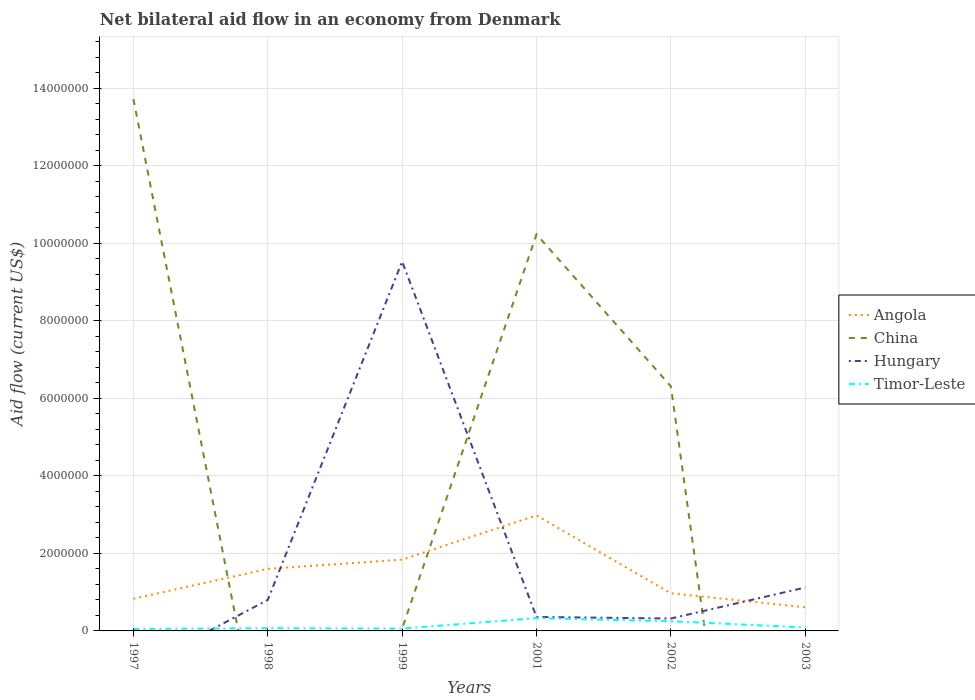Does the line corresponding to China intersect with the line corresponding to Angola?
Offer a very short reply. Yes. Across all years, what is the maximum net bilateral aid flow in Hungary?
Offer a very short reply. 0. What is the total net bilateral aid flow in China in the graph?
Ensure brevity in your answer.  3.49e+06. What is the difference between the highest and the second highest net bilateral aid flow in Hungary?
Your answer should be compact. 9.53e+06. Is the net bilateral aid flow in Timor-Leste strictly greater than the net bilateral aid flow in China over the years?
Your answer should be compact. No. How many years are there in the graph?
Offer a terse response. 6. Are the values on the major ticks of Y-axis written in scientific E-notation?
Provide a short and direct response. No. Does the graph contain grids?
Keep it short and to the point. Yes. How many legend labels are there?
Make the answer very short. 4. What is the title of the graph?
Make the answer very short. Net bilateral aid flow in an economy from Denmark. Does "Other small states" appear as one of the legend labels in the graph?
Ensure brevity in your answer.  No. What is the label or title of the X-axis?
Offer a terse response. Years. What is the Aid flow (current US$) of Angola in 1997?
Make the answer very short. 8.30e+05. What is the Aid flow (current US$) of China in 1997?
Keep it short and to the point. 1.37e+07. What is the Aid flow (current US$) of Angola in 1998?
Give a very brief answer. 1.60e+06. What is the Aid flow (current US$) of Angola in 1999?
Keep it short and to the point. 1.84e+06. What is the Aid flow (current US$) of Hungary in 1999?
Give a very brief answer. 9.53e+06. What is the Aid flow (current US$) of Angola in 2001?
Offer a terse response. 2.98e+06. What is the Aid flow (current US$) in China in 2001?
Give a very brief answer. 1.02e+07. What is the Aid flow (current US$) of Timor-Leste in 2001?
Offer a terse response. 3.30e+05. What is the Aid flow (current US$) in Angola in 2002?
Offer a very short reply. 9.70e+05. What is the Aid flow (current US$) of China in 2002?
Ensure brevity in your answer.  6.31e+06. What is the Aid flow (current US$) in Hungary in 2003?
Give a very brief answer. 1.12e+06. What is the Aid flow (current US$) of Timor-Leste in 2003?
Provide a succinct answer. 9.00e+04. Across all years, what is the maximum Aid flow (current US$) of Angola?
Your answer should be very brief. 2.98e+06. Across all years, what is the maximum Aid flow (current US$) in China?
Keep it short and to the point. 1.37e+07. Across all years, what is the maximum Aid flow (current US$) of Hungary?
Make the answer very short. 9.53e+06. Across all years, what is the minimum Aid flow (current US$) of Angola?
Make the answer very short. 6.10e+05. Across all years, what is the minimum Aid flow (current US$) of Timor-Leste?
Your response must be concise. 5.00e+04. What is the total Aid flow (current US$) in Angola in the graph?
Your answer should be very brief. 8.83e+06. What is the total Aid flow (current US$) of China in the graph?
Your response must be concise. 3.03e+07. What is the total Aid flow (current US$) in Hungary in the graph?
Your answer should be compact. 1.21e+07. What is the total Aid flow (current US$) of Timor-Leste in the graph?
Keep it short and to the point. 8.50e+05. What is the difference between the Aid flow (current US$) of Angola in 1997 and that in 1998?
Your answer should be very brief. -7.70e+05. What is the difference between the Aid flow (current US$) in Timor-Leste in 1997 and that in 1998?
Make the answer very short. -2.00e+04. What is the difference between the Aid flow (current US$) of Angola in 1997 and that in 1999?
Offer a terse response. -1.01e+06. What is the difference between the Aid flow (current US$) in China in 1997 and that in 1999?
Offer a terse response. 1.37e+07. What is the difference between the Aid flow (current US$) of Timor-Leste in 1997 and that in 1999?
Give a very brief answer. -10000. What is the difference between the Aid flow (current US$) in Angola in 1997 and that in 2001?
Make the answer very short. -2.15e+06. What is the difference between the Aid flow (current US$) in China in 1997 and that in 2001?
Offer a terse response. 3.49e+06. What is the difference between the Aid flow (current US$) of Timor-Leste in 1997 and that in 2001?
Offer a very short reply. -2.80e+05. What is the difference between the Aid flow (current US$) of China in 1997 and that in 2002?
Your answer should be compact. 7.41e+06. What is the difference between the Aid flow (current US$) in Timor-Leste in 1997 and that in 2003?
Keep it short and to the point. -4.00e+04. What is the difference between the Aid flow (current US$) of Hungary in 1998 and that in 1999?
Ensure brevity in your answer.  -8.73e+06. What is the difference between the Aid flow (current US$) in Angola in 1998 and that in 2001?
Keep it short and to the point. -1.38e+06. What is the difference between the Aid flow (current US$) in Hungary in 1998 and that in 2001?
Provide a short and direct response. 4.40e+05. What is the difference between the Aid flow (current US$) in Timor-Leste in 1998 and that in 2001?
Make the answer very short. -2.60e+05. What is the difference between the Aid flow (current US$) in Angola in 1998 and that in 2002?
Offer a terse response. 6.30e+05. What is the difference between the Aid flow (current US$) of Hungary in 1998 and that in 2002?
Provide a succinct answer. 4.80e+05. What is the difference between the Aid flow (current US$) in Timor-Leste in 1998 and that in 2002?
Your response must be concise. -1.80e+05. What is the difference between the Aid flow (current US$) of Angola in 1998 and that in 2003?
Provide a short and direct response. 9.90e+05. What is the difference between the Aid flow (current US$) in Hungary in 1998 and that in 2003?
Provide a short and direct response. -3.20e+05. What is the difference between the Aid flow (current US$) of Angola in 1999 and that in 2001?
Your answer should be compact. -1.14e+06. What is the difference between the Aid flow (current US$) of China in 1999 and that in 2001?
Your answer should be very brief. -1.02e+07. What is the difference between the Aid flow (current US$) in Hungary in 1999 and that in 2001?
Your answer should be very brief. 9.17e+06. What is the difference between the Aid flow (current US$) in Timor-Leste in 1999 and that in 2001?
Your answer should be compact. -2.70e+05. What is the difference between the Aid flow (current US$) of Angola in 1999 and that in 2002?
Offer a terse response. 8.70e+05. What is the difference between the Aid flow (current US$) of China in 1999 and that in 2002?
Offer a very short reply. -6.25e+06. What is the difference between the Aid flow (current US$) of Hungary in 1999 and that in 2002?
Your response must be concise. 9.21e+06. What is the difference between the Aid flow (current US$) in Timor-Leste in 1999 and that in 2002?
Your answer should be very brief. -1.90e+05. What is the difference between the Aid flow (current US$) of Angola in 1999 and that in 2003?
Keep it short and to the point. 1.23e+06. What is the difference between the Aid flow (current US$) of Hungary in 1999 and that in 2003?
Give a very brief answer. 8.41e+06. What is the difference between the Aid flow (current US$) of Angola in 2001 and that in 2002?
Your response must be concise. 2.01e+06. What is the difference between the Aid flow (current US$) in China in 2001 and that in 2002?
Make the answer very short. 3.92e+06. What is the difference between the Aid flow (current US$) of Hungary in 2001 and that in 2002?
Ensure brevity in your answer.  4.00e+04. What is the difference between the Aid flow (current US$) of Angola in 2001 and that in 2003?
Give a very brief answer. 2.37e+06. What is the difference between the Aid flow (current US$) of Hungary in 2001 and that in 2003?
Provide a short and direct response. -7.60e+05. What is the difference between the Aid flow (current US$) of Timor-Leste in 2001 and that in 2003?
Provide a short and direct response. 2.40e+05. What is the difference between the Aid flow (current US$) of Angola in 2002 and that in 2003?
Offer a very short reply. 3.60e+05. What is the difference between the Aid flow (current US$) in Hungary in 2002 and that in 2003?
Make the answer very short. -8.00e+05. What is the difference between the Aid flow (current US$) of Angola in 1997 and the Aid flow (current US$) of Hungary in 1998?
Make the answer very short. 3.00e+04. What is the difference between the Aid flow (current US$) of Angola in 1997 and the Aid flow (current US$) of Timor-Leste in 1998?
Your answer should be very brief. 7.60e+05. What is the difference between the Aid flow (current US$) in China in 1997 and the Aid flow (current US$) in Hungary in 1998?
Make the answer very short. 1.29e+07. What is the difference between the Aid flow (current US$) in China in 1997 and the Aid flow (current US$) in Timor-Leste in 1998?
Ensure brevity in your answer.  1.36e+07. What is the difference between the Aid flow (current US$) of Angola in 1997 and the Aid flow (current US$) of China in 1999?
Provide a short and direct response. 7.70e+05. What is the difference between the Aid flow (current US$) of Angola in 1997 and the Aid flow (current US$) of Hungary in 1999?
Your answer should be compact. -8.70e+06. What is the difference between the Aid flow (current US$) of Angola in 1997 and the Aid flow (current US$) of Timor-Leste in 1999?
Keep it short and to the point. 7.70e+05. What is the difference between the Aid flow (current US$) in China in 1997 and the Aid flow (current US$) in Hungary in 1999?
Ensure brevity in your answer.  4.19e+06. What is the difference between the Aid flow (current US$) in China in 1997 and the Aid flow (current US$) in Timor-Leste in 1999?
Your answer should be very brief. 1.37e+07. What is the difference between the Aid flow (current US$) in Angola in 1997 and the Aid flow (current US$) in China in 2001?
Provide a short and direct response. -9.40e+06. What is the difference between the Aid flow (current US$) of Angola in 1997 and the Aid flow (current US$) of Hungary in 2001?
Your response must be concise. 4.70e+05. What is the difference between the Aid flow (current US$) in Angola in 1997 and the Aid flow (current US$) in Timor-Leste in 2001?
Your answer should be very brief. 5.00e+05. What is the difference between the Aid flow (current US$) in China in 1997 and the Aid flow (current US$) in Hungary in 2001?
Provide a short and direct response. 1.34e+07. What is the difference between the Aid flow (current US$) in China in 1997 and the Aid flow (current US$) in Timor-Leste in 2001?
Make the answer very short. 1.34e+07. What is the difference between the Aid flow (current US$) in Angola in 1997 and the Aid flow (current US$) in China in 2002?
Provide a short and direct response. -5.48e+06. What is the difference between the Aid flow (current US$) in Angola in 1997 and the Aid flow (current US$) in Hungary in 2002?
Provide a succinct answer. 5.10e+05. What is the difference between the Aid flow (current US$) in Angola in 1997 and the Aid flow (current US$) in Timor-Leste in 2002?
Offer a very short reply. 5.80e+05. What is the difference between the Aid flow (current US$) of China in 1997 and the Aid flow (current US$) of Hungary in 2002?
Keep it short and to the point. 1.34e+07. What is the difference between the Aid flow (current US$) of China in 1997 and the Aid flow (current US$) of Timor-Leste in 2002?
Offer a very short reply. 1.35e+07. What is the difference between the Aid flow (current US$) of Angola in 1997 and the Aid flow (current US$) of Timor-Leste in 2003?
Provide a succinct answer. 7.40e+05. What is the difference between the Aid flow (current US$) of China in 1997 and the Aid flow (current US$) of Hungary in 2003?
Offer a terse response. 1.26e+07. What is the difference between the Aid flow (current US$) in China in 1997 and the Aid flow (current US$) in Timor-Leste in 2003?
Your answer should be very brief. 1.36e+07. What is the difference between the Aid flow (current US$) of Angola in 1998 and the Aid flow (current US$) of China in 1999?
Make the answer very short. 1.54e+06. What is the difference between the Aid flow (current US$) in Angola in 1998 and the Aid flow (current US$) in Hungary in 1999?
Your response must be concise. -7.93e+06. What is the difference between the Aid flow (current US$) in Angola in 1998 and the Aid flow (current US$) in Timor-Leste in 1999?
Make the answer very short. 1.54e+06. What is the difference between the Aid flow (current US$) in Hungary in 1998 and the Aid flow (current US$) in Timor-Leste in 1999?
Your response must be concise. 7.40e+05. What is the difference between the Aid flow (current US$) of Angola in 1998 and the Aid flow (current US$) of China in 2001?
Your response must be concise. -8.63e+06. What is the difference between the Aid flow (current US$) of Angola in 1998 and the Aid flow (current US$) of Hungary in 2001?
Offer a very short reply. 1.24e+06. What is the difference between the Aid flow (current US$) in Angola in 1998 and the Aid flow (current US$) in Timor-Leste in 2001?
Give a very brief answer. 1.27e+06. What is the difference between the Aid flow (current US$) in Hungary in 1998 and the Aid flow (current US$) in Timor-Leste in 2001?
Offer a very short reply. 4.70e+05. What is the difference between the Aid flow (current US$) in Angola in 1998 and the Aid flow (current US$) in China in 2002?
Provide a short and direct response. -4.71e+06. What is the difference between the Aid flow (current US$) in Angola in 1998 and the Aid flow (current US$) in Hungary in 2002?
Offer a very short reply. 1.28e+06. What is the difference between the Aid flow (current US$) of Angola in 1998 and the Aid flow (current US$) of Timor-Leste in 2002?
Keep it short and to the point. 1.35e+06. What is the difference between the Aid flow (current US$) in Angola in 1998 and the Aid flow (current US$) in Timor-Leste in 2003?
Provide a succinct answer. 1.51e+06. What is the difference between the Aid flow (current US$) of Hungary in 1998 and the Aid flow (current US$) of Timor-Leste in 2003?
Your answer should be compact. 7.10e+05. What is the difference between the Aid flow (current US$) in Angola in 1999 and the Aid flow (current US$) in China in 2001?
Provide a short and direct response. -8.39e+06. What is the difference between the Aid flow (current US$) of Angola in 1999 and the Aid flow (current US$) of Hungary in 2001?
Make the answer very short. 1.48e+06. What is the difference between the Aid flow (current US$) in Angola in 1999 and the Aid flow (current US$) in Timor-Leste in 2001?
Offer a very short reply. 1.51e+06. What is the difference between the Aid flow (current US$) in China in 1999 and the Aid flow (current US$) in Timor-Leste in 2001?
Your answer should be very brief. -2.70e+05. What is the difference between the Aid flow (current US$) of Hungary in 1999 and the Aid flow (current US$) of Timor-Leste in 2001?
Offer a terse response. 9.20e+06. What is the difference between the Aid flow (current US$) of Angola in 1999 and the Aid flow (current US$) of China in 2002?
Your answer should be compact. -4.47e+06. What is the difference between the Aid flow (current US$) of Angola in 1999 and the Aid flow (current US$) of Hungary in 2002?
Your answer should be very brief. 1.52e+06. What is the difference between the Aid flow (current US$) in Angola in 1999 and the Aid flow (current US$) in Timor-Leste in 2002?
Make the answer very short. 1.59e+06. What is the difference between the Aid flow (current US$) of China in 1999 and the Aid flow (current US$) of Timor-Leste in 2002?
Offer a terse response. -1.90e+05. What is the difference between the Aid flow (current US$) of Hungary in 1999 and the Aid flow (current US$) of Timor-Leste in 2002?
Offer a terse response. 9.28e+06. What is the difference between the Aid flow (current US$) in Angola in 1999 and the Aid flow (current US$) in Hungary in 2003?
Provide a short and direct response. 7.20e+05. What is the difference between the Aid flow (current US$) of Angola in 1999 and the Aid flow (current US$) of Timor-Leste in 2003?
Offer a very short reply. 1.75e+06. What is the difference between the Aid flow (current US$) in China in 1999 and the Aid flow (current US$) in Hungary in 2003?
Offer a very short reply. -1.06e+06. What is the difference between the Aid flow (current US$) of Hungary in 1999 and the Aid flow (current US$) of Timor-Leste in 2003?
Offer a terse response. 9.44e+06. What is the difference between the Aid flow (current US$) of Angola in 2001 and the Aid flow (current US$) of China in 2002?
Provide a short and direct response. -3.33e+06. What is the difference between the Aid flow (current US$) of Angola in 2001 and the Aid flow (current US$) of Hungary in 2002?
Ensure brevity in your answer.  2.66e+06. What is the difference between the Aid flow (current US$) of Angola in 2001 and the Aid flow (current US$) of Timor-Leste in 2002?
Ensure brevity in your answer.  2.73e+06. What is the difference between the Aid flow (current US$) in China in 2001 and the Aid flow (current US$) in Hungary in 2002?
Your response must be concise. 9.91e+06. What is the difference between the Aid flow (current US$) of China in 2001 and the Aid flow (current US$) of Timor-Leste in 2002?
Ensure brevity in your answer.  9.98e+06. What is the difference between the Aid flow (current US$) of Angola in 2001 and the Aid flow (current US$) of Hungary in 2003?
Make the answer very short. 1.86e+06. What is the difference between the Aid flow (current US$) in Angola in 2001 and the Aid flow (current US$) in Timor-Leste in 2003?
Give a very brief answer. 2.89e+06. What is the difference between the Aid flow (current US$) in China in 2001 and the Aid flow (current US$) in Hungary in 2003?
Provide a succinct answer. 9.11e+06. What is the difference between the Aid flow (current US$) of China in 2001 and the Aid flow (current US$) of Timor-Leste in 2003?
Your response must be concise. 1.01e+07. What is the difference between the Aid flow (current US$) in Angola in 2002 and the Aid flow (current US$) in Hungary in 2003?
Ensure brevity in your answer.  -1.50e+05. What is the difference between the Aid flow (current US$) in Angola in 2002 and the Aid flow (current US$) in Timor-Leste in 2003?
Your answer should be compact. 8.80e+05. What is the difference between the Aid flow (current US$) of China in 2002 and the Aid flow (current US$) of Hungary in 2003?
Your answer should be compact. 5.19e+06. What is the difference between the Aid flow (current US$) in China in 2002 and the Aid flow (current US$) in Timor-Leste in 2003?
Provide a succinct answer. 6.22e+06. What is the average Aid flow (current US$) of Angola per year?
Keep it short and to the point. 1.47e+06. What is the average Aid flow (current US$) in China per year?
Provide a succinct answer. 5.05e+06. What is the average Aid flow (current US$) of Hungary per year?
Provide a short and direct response. 2.02e+06. What is the average Aid flow (current US$) in Timor-Leste per year?
Give a very brief answer. 1.42e+05. In the year 1997, what is the difference between the Aid flow (current US$) of Angola and Aid flow (current US$) of China?
Give a very brief answer. -1.29e+07. In the year 1997, what is the difference between the Aid flow (current US$) of Angola and Aid flow (current US$) of Timor-Leste?
Keep it short and to the point. 7.80e+05. In the year 1997, what is the difference between the Aid flow (current US$) in China and Aid flow (current US$) in Timor-Leste?
Keep it short and to the point. 1.37e+07. In the year 1998, what is the difference between the Aid flow (current US$) in Angola and Aid flow (current US$) in Hungary?
Your answer should be very brief. 8.00e+05. In the year 1998, what is the difference between the Aid flow (current US$) in Angola and Aid flow (current US$) in Timor-Leste?
Offer a very short reply. 1.53e+06. In the year 1998, what is the difference between the Aid flow (current US$) of Hungary and Aid flow (current US$) of Timor-Leste?
Provide a succinct answer. 7.30e+05. In the year 1999, what is the difference between the Aid flow (current US$) in Angola and Aid flow (current US$) in China?
Provide a succinct answer. 1.78e+06. In the year 1999, what is the difference between the Aid flow (current US$) of Angola and Aid flow (current US$) of Hungary?
Your answer should be very brief. -7.69e+06. In the year 1999, what is the difference between the Aid flow (current US$) in Angola and Aid flow (current US$) in Timor-Leste?
Give a very brief answer. 1.78e+06. In the year 1999, what is the difference between the Aid flow (current US$) in China and Aid flow (current US$) in Hungary?
Provide a succinct answer. -9.47e+06. In the year 1999, what is the difference between the Aid flow (current US$) of Hungary and Aid flow (current US$) of Timor-Leste?
Ensure brevity in your answer.  9.47e+06. In the year 2001, what is the difference between the Aid flow (current US$) in Angola and Aid flow (current US$) in China?
Make the answer very short. -7.25e+06. In the year 2001, what is the difference between the Aid flow (current US$) in Angola and Aid flow (current US$) in Hungary?
Offer a very short reply. 2.62e+06. In the year 2001, what is the difference between the Aid flow (current US$) in Angola and Aid flow (current US$) in Timor-Leste?
Your answer should be compact. 2.65e+06. In the year 2001, what is the difference between the Aid flow (current US$) of China and Aid flow (current US$) of Hungary?
Your answer should be compact. 9.87e+06. In the year 2001, what is the difference between the Aid flow (current US$) of China and Aid flow (current US$) of Timor-Leste?
Offer a terse response. 9.90e+06. In the year 2002, what is the difference between the Aid flow (current US$) of Angola and Aid flow (current US$) of China?
Provide a short and direct response. -5.34e+06. In the year 2002, what is the difference between the Aid flow (current US$) of Angola and Aid flow (current US$) of Hungary?
Your answer should be very brief. 6.50e+05. In the year 2002, what is the difference between the Aid flow (current US$) in Angola and Aid flow (current US$) in Timor-Leste?
Offer a terse response. 7.20e+05. In the year 2002, what is the difference between the Aid flow (current US$) of China and Aid flow (current US$) of Hungary?
Provide a short and direct response. 5.99e+06. In the year 2002, what is the difference between the Aid flow (current US$) of China and Aid flow (current US$) of Timor-Leste?
Your answer should be compact. 6.06e+06. In the year 2003, what is the difference between the Aid flow (current US$) in Angola and Aid flow (current US$) in Hungary?
Offer a very short reply. -5.10e+05. In the year 2003, what is the difference between the Aid flow (current US$) of Angola and Aid flow (current US$) of Timor-Leste?
Your answer should be compact. 5.20e+05. In the year 2003, what is the difference between the Aid flow (current US$) in Hungary and Aid flow (current US$) in Timor-Leste?
Keep it short and to the point. 1.03e+06. What is the ratio of the Aid flow (current US$) in Angola in 1997 to that in 1998?
Your response must be concise. 0.52. What is the ratio of the Aid flow (current US$) in Timor-Leste in 1997 to that in 1998?
Make the answer very short. 0.71. What is the ratio of the Aid flow (current US$) of Angola in 1997 to that in 1999?
Offer a very short reply. 0.45. What is the ratio of the Aid flow (current US$) of China in 1997 to that in 1999?
Keep it short and to the point. 228.67. What is the ratio of the Aid flow (current US$) of Timor-Leste in 1997 to that in 1999?
Make the answer very short. 0.83. What is the ratio of the Aid flow (current US$) of Angola in 1997 to that in 2001?
Provide a succinct answer. 0.28. What is the ratio of the Aid flow (current US$) of China in 1997 to that in 2001?
Make the answer very short. 1.34. What is the ratio of the Aid flow (current US$) of Timor-Leste in 1997 to that in 2001?
Ensure brevity in your answer.  0.15. What is the ratio of the Aid flow (current US$) of Angola in 1997 to that in 2002?
Give a very brief answer. 0.86. What is the ratio of the Aid flow (current US$) in China in 1997 to that in 2002?
Your answer should be compact. 2.17. What is the ratio of the Aid flow (current US$) of Timor-Leste in 1997 to that in 2002?
Offer a terse response. 0.2. What is the ratio of the Aid flow (current US$) in Angola in 1997 to that in 2003?
Offer a very short reply. 1.36. What is the ratio of the Aid flow (current US$) in Timor-Leste in 1997 to that in 2003?
Provide a short and direct response. 0.56. What is the ratio of the Aid flow (current US$) of Angola in 1998 to that in 1999?
Give a very brief answer. 0.87. What is the ratio of the Aid flow (current US$) in Hungary in 1998 to that in 1999?
Make the answer very short. 0.08. What is the ratio of the Aid flow (current US$) in Angola in 1998 to that in 2001?
Make the answer very short. 0.54. What is the ratio of the Aid flow (current US$) in Hungary in 1998 to that in 2001?
Provide a succinct answer. 2.22. What is the ratio of the Aid flow (current US$) in Timor-Leste in 1998 to that in 2001?
Offer a very short reply. 0.21. What is the ratio of the Aid flow (current US$) in Angola in 1998 to that in 2002?
Keep it short and to the point. 1.65. What is the ratio of the Aid flow (current US$) of Hungary in 1998 to that in 2002?
Give a very brief answer. 2.5. What is the ratio of the Aid flow (current US$) in Timor-Leste in 1998 to that in 2002?
Your answer should be very brief. 0.28. What is the ratio of the Aid flow (current US$) in Angola in 1998 to that in 2003?
Offer a very short reply. 2.62. What is the ratio of the Aid flow (current US$) of Angola in 1999 to that in 2001?
Your response must be concise. 0.62. What is the ratio of the Aid flow (current US$) of China in 1999 to that in 2001?
Give a very brief answer. 0.01. What is the ratio of the Aid flow (current US$) in Hungary in 1999 to that in 2001?
Provide a short and direct response. 26.47. What is the ratio of the Aid flow (current US$) of Timor-Leste in 1999 to that in 2001?
Keep it short and to the point. 0.18. What is the ratio of the Aid flow (current US$) of Angola in 1999 to that in 2002?
Provide a succinct answer. 1.9. What is the ratio of the Aid flow (current US$) of China in 1999 to that in 2002?
Give a very brief answer. 0.01. What is the ratio of the Aid flow (current US$) of Hungary in 1999 to that in 2002?
Give a very brief answer. 29.78. What is the ratio of the Aid flow (current US$) in Timor-Leste in 1999 to that in 2002?
Ensure brevity in your answer.  0.24. What is the ratio of the Aid flow (current US$) of Angola in 1999 to that in 2003?
Your answer should be very brief. 3.02. What is the ratio of the Aid flow (current US$) in Hungary in 1999 to that in 2003?
Ensure brevity in your answer.  8.51. What is the ratio of the Aid flow (current US$) of Timor-Leste in 1999 to that in 2003?
Provide a succinct answer. 0.67. What is the ratio of the Aid flow (current US$) of Angola in 2001 to that in 2002?
Offer a very short reply. 3.07. What is the ratio of the Aid flow (current US$) of China in 2001 to that in 2002?
Offer a very short reply. 1.62. What is the ratio of the Aid flow (current US$) of Timor-Leste in 2001 to that in 2002?
Your answer should be compact. 1.32. What is the ratio of the Aid flow (current US$) in Angola in 2001 to that in 2003?
Keep it short and to the point. 4.89. What is the ratio of the Aid flow (current US$) of Hungary in 2001 to that in 2003?
Your answer should be compact. 0.32. What is the ratio of the Aid flow (current US$) of Timor-Leste in 2001 to that in 2003?
Ensure brevity in your answer.  3.67. What is the ratio of the Aid flow (current US$) of Angola in 2002 to that in 2003?
Provide a succinct answer. 1.59. What is the ratio of the Aid flow (current US$) of Hungary in 2002 to that in 2003?
Make the answer very short. 0.29. What is the ratio of the Aid flow (current US$) in Timor-Leste in 2002 to that in 2003?
Your answer should be very brief. 2.78. What is the difference between the highest and the second highest Aid flow (current US$) in Angola?
Provide a succinct answer. 1.14e+06. What is the difference between the highest and the second highest Aid flow (current US$) in China?
Your answer should be very brief. 3.49e+06. What is the difference between the highest and the second highest Aid flow (current US$) in Hungary?
Offer a terse response. 8.41e+06. What is the difference between the highest and the lowest Aid flow (current US$) of Angola?
Make the answer very short. 2.37e+06. What is the difference between the highest and the lowest Aid flow (current US$) in China?
Offer a terse response. 1.37e+07. What is the difference between the highest and the lowest Aid flow (current US$) of Hungary?
Provide a short and direct response. 9.53e+06. 